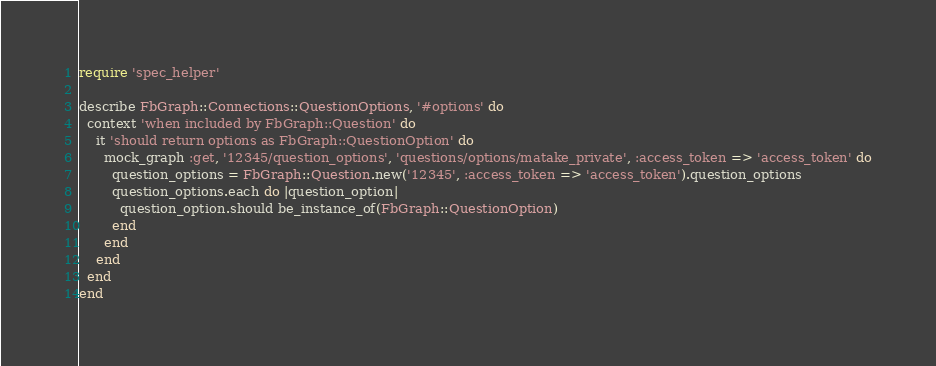Convert code to text. <code><loc_0><loc_0><loc_500><loc_500><_Ruby_>require 'spec_helper'

describe FbGraph::Connections::QuestionOptions, '#options' do
  context 'when included by FbGraph::Question' do
    it 'should return options as FbGraph::QuestionOption' do
      mock_graph :get, '12345/question_options', 'questions/options/matake_private', :access_token => 'access_token' do
        question_options = FbGraph::Question.new('12345', :access_token => 'access_token').question_options
        question_options.each do |question_option|
          question_option.should be_instance_of(FbGraph::QuestionOption)
        end
      end
    end
  end
end
</code> 